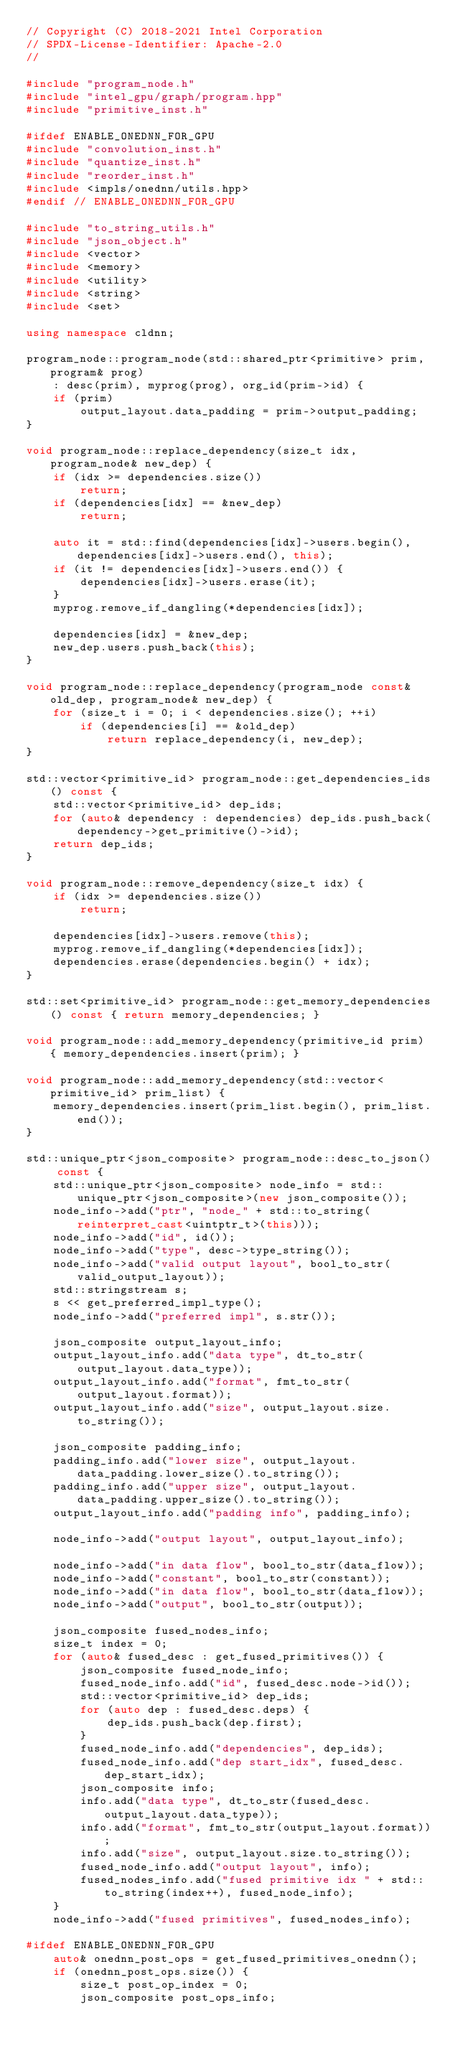Convert code to text. <code><loc_0><loc_0><loc_500><loc_500><_C++_>// Copyright (C) 2018-2021 Intel Corporation
// SPDX-License-Identifier: Apache-2.0
//

#include "program_node.h"
#include "intel_gpu/graph/program.hpp"
#include "primitive_inst.h"

#ifdef ENABLE_ONEDNN_FOR_GPU
#include "convolution_inst.h"
#include "quantize_inst.h"
#include "reorder_inst.h"
#include <impls/onednn/utils.hpp>
#endif // ENABLE_ONEDNN_FOR_GPU

#include "to_string_utils.h"
#include "json_object.h"
#include <vector>
#include <memory>
#include <utility>
#include <string>
#include <set>

using namespace cldnn;

program_node::program_node(std::shared_ptr<primitive> prim, program& prog)
    : desc(prim), myprog(prog), org_id(prim->id) {
    if (prim)
        output_layout.data_padding = prim->output_padding;
}

void program_node::replace_dependency(size_t idx, program_node& new_dep) {
    if (idx >= dependencies.size())
        return;
    if (dependencies[idx] == &new_dep)
        return;

    auto it = std::find(dependencies[idx]->users.begin(), dependencies[idx]->users.end(), this);
    if (it != dependencies[idx]->users.end()) {
        dependencies[idx]->users.erase(it);
    }
    myprog.remove_if_dangling(*dependencies[idx]);

    dependencies[idx] = &new_dep;
    new_dep.users.push_back(this);
}

void program_node::replace_dependency(program_node const& old_dep, program_node& new_dep) {
    for (size_t i = 0; i < dependencies.size(); ++i)
        if (dependencies[i] == &old_dep)
            return replace_dependency(i, new_dep);
}

std::vector<primitive_id> program_node::get_dependencies_ids() const {
    std::vector<primitive_id> dep_ids;
    for (auto& dependency : dependencies) dep_ids.push_back(dependency->get_primitive()->id);
    return dep_ids;
}

void program_node::remove_dependency(size_t idx) {
    if (idx >= dependencies.size())
        return;

    dependencies[idx]->users.remove(this);
    myprog.remove_if_dangling(*dependencies[idx]);
    dependencies.erase(dependencies.begin() + idx);
}

std::set<primitive_id> program_node::get_memory_dependencies() const { return memory_dependencies; }

void program_node::add_memory_dependency(primitive_id prim) { memory_dependencies.insert(prim); }

void program_node::add_memory_dependency(std::vector<primitive_id> prim_list) {
    memory_dependencies.insert(prim_list.begin(), prim_list.end());
}

std::unique_ptr<json_composite> program_node::desc_to_json() const {
    std::unique_ptr<json_composite> node_info = std::unique_ptr<json_composite>(new json_composite());
    node_info->add("ptr", "node_" + std::to_string(reinterpret_cast<uintptr_t>(this)));
    node_info->add("id", id());
    node_info->add("type", desc->type_string());
    node_info->add("valid output layout", bool_to_str(valid_output_layout));
    std::stringstream s;
    s << get_preferred_impl_type();
    node_info->add("preferred impl", s.str());

    json_composite output_layout_info;
    output_layout_info.add("data type", dt_to_str(output_layout.data_type));
    output_layout_info.add("format", fmt_to_str(output_layout.format));
    output_layout_info.add("size", output_layout.size.to_string());

    json_composite padding_info;
    padding_info.add("lower size", output_layout.data_padding.lower_size().to_string());
    padding_info.add("upper size", output_layout.data_padding.upper_size().to_string());
    output_layout_info.add("padding info", padding_info);

    node_info->add("output layout", output_layout_info);

    node_info->add("in data flow", bool_to_str(data_flow));
    node_info->add("constant", bool_to_str(constant));
    node_info->add("in data flow", bool_to_str(data_flow));
    node_info->add("output", bool_to_str(output));

    json_composite fused_nodes_info;
    size_t index = 0;
    for (auto& fused_desc : get_fused_primitives()) {
        json_composite fused_node_info;
        fused_node_info.add("id", fused_desc.node->id());
        std::vector<primitive_id> dep_ids;
        for (auto dep : fused_desc.deps) {
            dep_ids.push_back(dep.first);
        }
        fused_node_info.add("dependencies", dep_ids);
        fused_node_info.add("dep start_idx", fused_desc.dep_start_idx);
        json_composite info;
        info.add("data type", dt_to_str(fused_desc.output_layout.data_type));
        info.add("format", fmt_to_str(output_layout.format));
        info.add("size", output_layout.size.to_string());
        fused_node_info.add("output layout", info);
        fused_nodes_info.add("fused primitive idx " + std::to_string(index++), fused_node_info);
    }
    node_info->add("fused primitives", fused_nodes_info);

#ifdef ENABLE_ONEDNN_FOR_GPU
    auto& onednn_post_ops = get_fused_primitives_onednn();
    if (onednn_post_ops.size()) {
        size_t post_op_index = 0;
        json_composite post_ops_info;</code> 